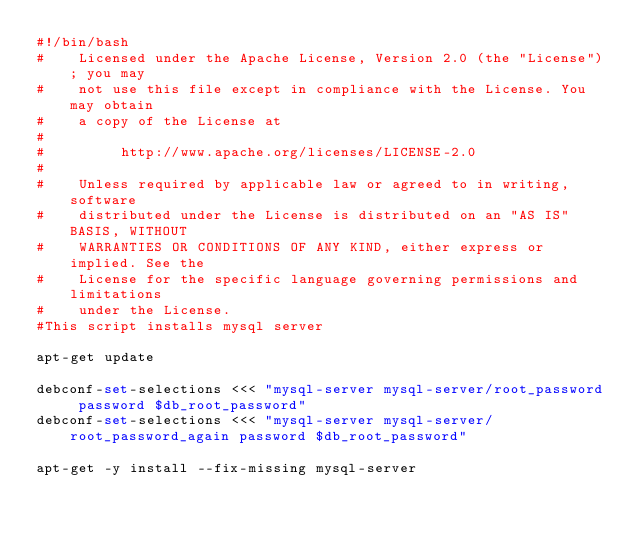Convert code to text. <code><loc_0><loc_0><loc_500><loc_500><_Bash_>#!/bin/bash
#    Licensed under the Apache License, Version 2.0 (the "License"); you may
#    not use this file except in compliance with the License. You may obtain
#    a copy of the License at
#
#         http://www.apache.org/licenses/LICENSE-2.0
#
#    Unless required by applicable law or agreed to in writing, software
#    distributed under the License is distributed on an "AS IS" BASIS, WITHOUT
#    WARRANTIES OR CONDITIONS OF ANY KIND, either express or implied. See the
#    License for the specific language governing permissions and limitations
#    under the License.
#This script installs mysql server

apt-get update

debconf-set-selections <<< "mysql-server mysql-server/root_password password $db_root_password"
debconf-set-selections <<< "mysql-server mysql-server/root_password_again password $db_root_password"

apt-get -y install --fix-missing mysql-server</code> 